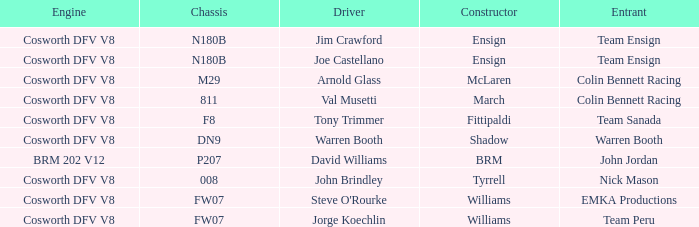Parse the full table. {'header': ['Engine', 'Chassis', 'Driver', 'Constructor', 'Entrant'], 'rows': [['Cosworth DFV V8', 'N180B', 'Jim Crawford', 'Ensign', 'Team Ensign'], ['Cosworth DFV V8', 'N180B', 'Joe Castellano', 'Ensign', 'Team Ensign'], ['Cosworth DFV V8', 'M29', 'Arnold Glass', 'McLaren', 'Colin Bennett Racing'], ['Cosworth DFV V8', '811', 'Val Musetti', 'March', 'Colin Bennett Racing'], ['Cosworth DFV V8', 'F8', 'Tony Trimmer', 'Fittipaldi', 'Team Sanada'], ['Cosworth DFV V8', 'DN9', 'Warren Booth', 'Shadow', 'Warren Booth'], ['BRM 202 V12', 'P207', 'David Williams', 'BRM', 'John Jordan'], ['Cosworth DFV V8', '008', 'John Brindley', 'Tyrrell', 'Nick Mason'], ['Cosworth DFV V8', 'FW07', "Steve O'Rourke", 'Williams', 'EMKA Productions'], ['Cosworth DFV V8', 'FW07', 'Jorge Koechlin', 'Williams', 'Team Peru']]} What group employs a cosworth dfv v8 engine and dn9 chassis? Warren Booth. 